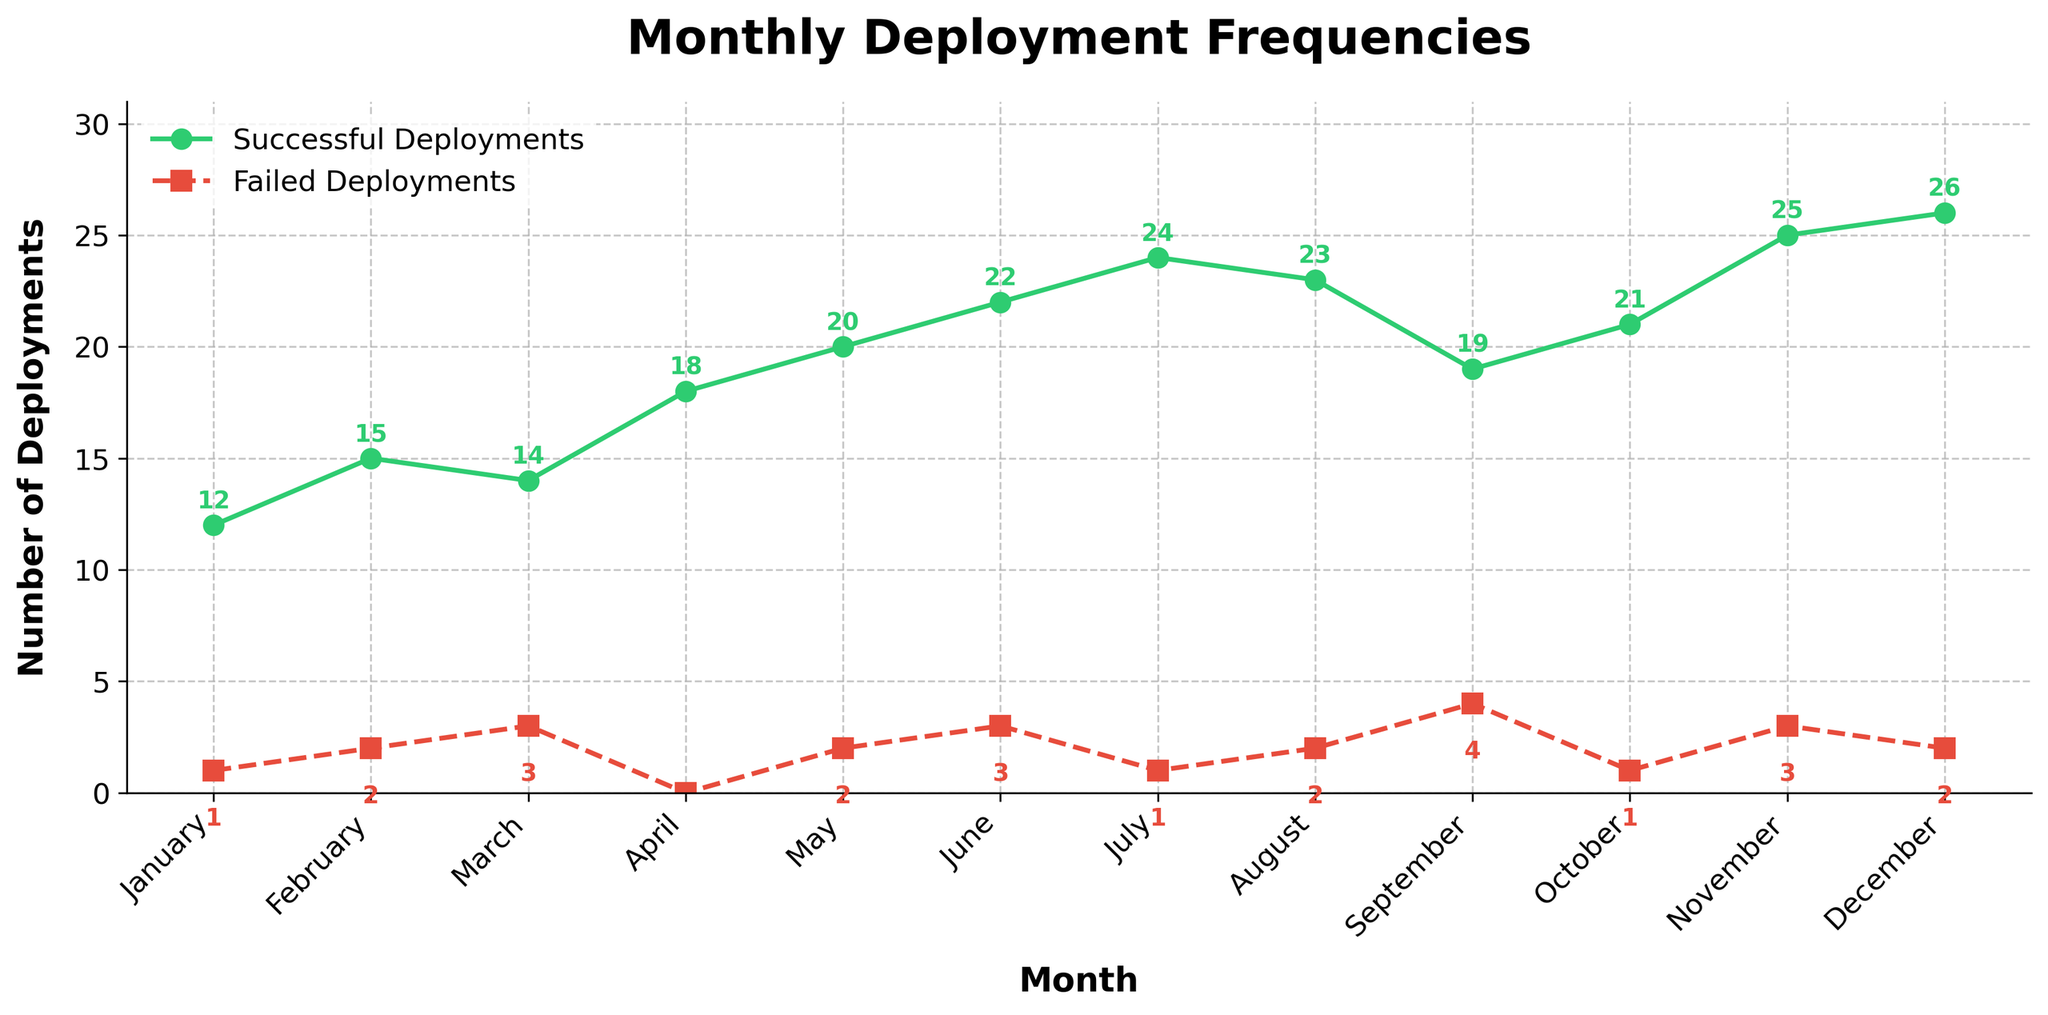What is the title of the plot? The title of the plot is usually displayed at the top and describes the overall content of the figure. In this plot, it reads 'Monthly Deployment Frequencies'.
Answer: Monthly Deployment Frequencies What color represents successful deployments? The line representing successful deployments is colored different from the line for failed deployments. The successful deployments line is green.
Answer: Green Which month had the highest number of successful deployments? To find the month with the highest number of successful deployments, locate the peak point on the successful deployments line. December has the highest number at 26.
Answer: December What is the difference between successful and failed deployments in March? Subtract the number of failed deployments in March from the number of successful deployments: 14 - 3 = 11.
Answer: 11 Which month had the lowest number of failed deployments? Locate the lowest point on the failed deployments line. April had the lowest number of failed deployments, which is 0.
Answer: April How many months had more than 20 successful deployments? Count the months with successful deployment values greater than 20: June (22), July (24), November (25), December (26).
Answer: 4 What is the average number of successful deployments over the year? Sum up all the successful deployments and divide by the number of months: (12+15+14+18+20+22+24+23+19+21+25+26) / 12 = 19.08.
Answer: 19.08 Which month had the greatest difference between successful and failed deployments? Calculate the difference for each month and identify the largest: December (26-2=24) has the greatest difference.
Answer: December How does the trend of successful deployments compare to failed deployments over the year? Observe the pattern of increasing or decreasing values. Both successful and failed deployments generally increase, but successful deployments increase more consistently.
Answer: Successful deployments increase more consistently What is the overall trend of successful deployments from January to December? Follow the green line from start to end; it shows a general increase in successful deployments from January (12) to December (26).
Answer: Increasing 